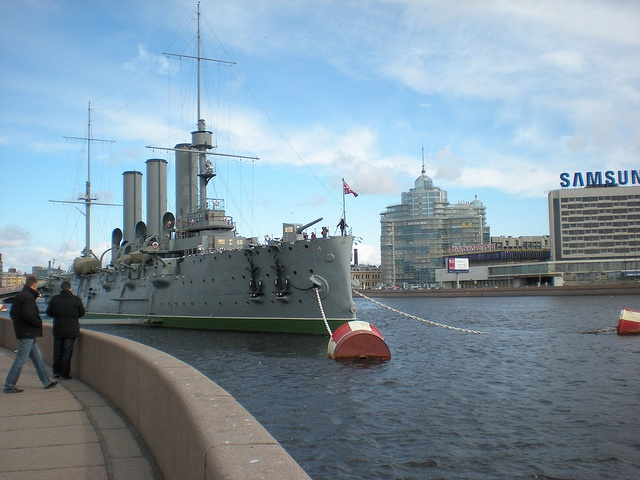Describe the objects in this image and their specific colors. I can see boat in darkgray, gray, lightblue, and black tones, people in darkgray, black, gray, purple, and darkblue tones, people in darkgray, black, gray, and darkblue tones, people in darkgray, black, navy, and gray tones, and people in darkgray, gray, white, and navy tones in this image. 